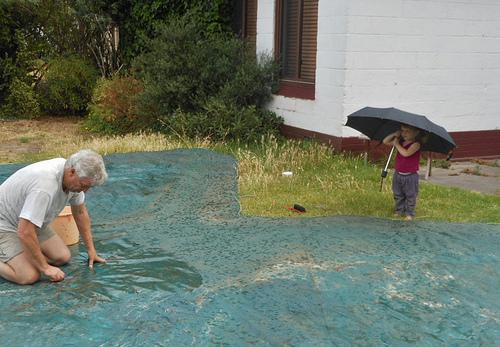Question: where is this scene probably taking place?
Choices:
A. Front yard.
B. Side yard.
C. Grave yard.
D. Backyard.
Answer with the letter. Answer: D Question: what does the older person appear to be kneeling on?
Choices:
A. Large piece of steel.
B. Large piece of plastic.
C. Large piece of metal.
D. Large piece of gold.
Answer with the letter. Answer: B Question: how is the older person looking?
Choices:
A. Up.
B. Left.
C. Down.
D. Right.
Answer with the letter. Answer: C Question: what is primary color of house seen in photo?
Choices:
A. Black.
B. White.
C. Red.
D. Blue.
Answer with the letter. Answer: B 